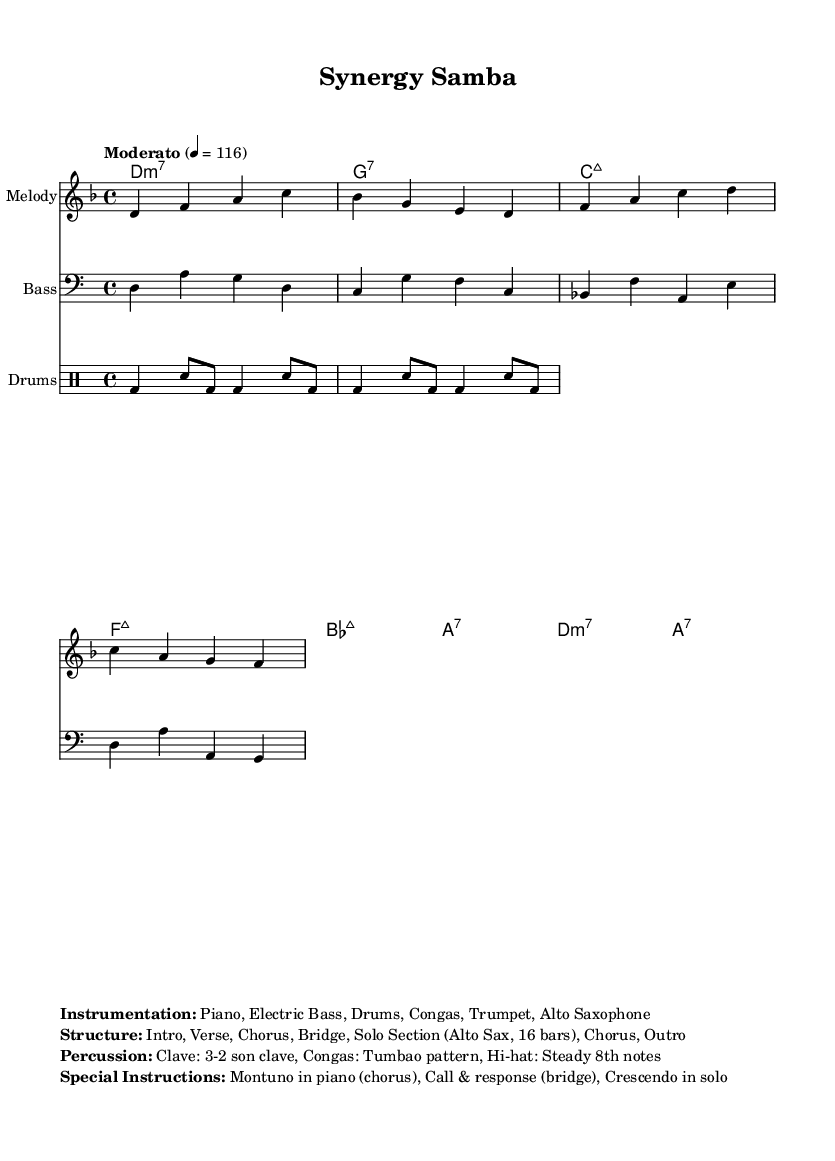What is the key signature of this music? The key signature indicated is D minor, which has one flat (B flat). This can be determined by examining the global section of the code where it explicitly states "d \minor".
Answer: D minor What is the time signature of this piece? The time signature is 4/4, which can be found in the global section of the code just before the key signature is mentioned.
Answer: 4/4 What is the tempo marking for this music? The tempo marking is "Moderato", which is noted in the global section with a tempo of 116 beats per minute. This indicates a moderate pace for the piece.
Answer: Moderato How many chords are in the chord progression? There are eight chords listed in the chordNames section, which can be counted as each entry in the chord mode corresponds to one chord.
Answer: 8 What percussion pattern is specified in this composition? The drumming pattern is defined as a bass drum and snare pattern described in the drummode section. It shows rhythmic patterns that repeat in bars of 4.
Answer: BD and SN What special instructions are provided for the piano section? The special instruction provided for the piano is to play a Montuno during the chorus. This indicates a specific rhythmic pattern typical of Latin music that should be performed.
Answer: Montuno What instruments are featured in this composition? The instrumentation includes Piano, Electric Bass, Drums, Congas, Trumpet, and Alto Saxophone, as outlined in the markup section of the code.
Answer: Piano, Electric Bass, Drums, Congas, Trumpet, Alto Saxophone 